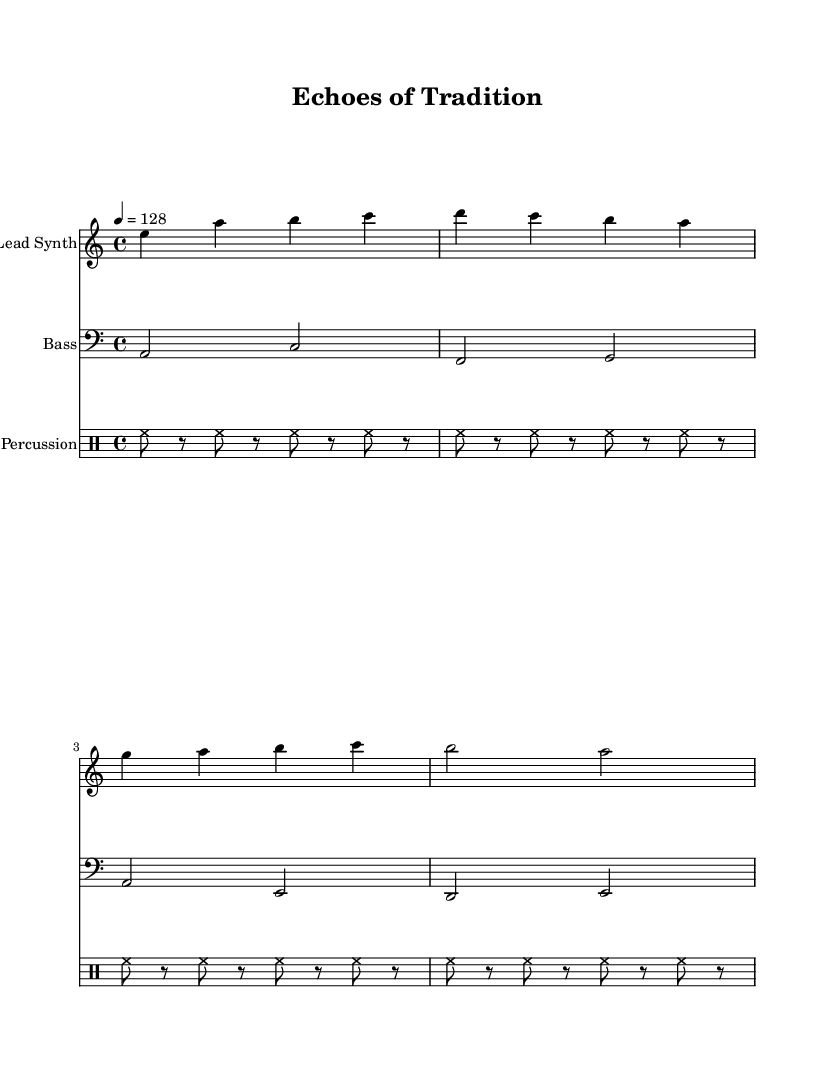What is the key signature of this music? The key signature is A minor, which has no sharps or flats.
Answer: A minor What is the time signature of this music? The time signature is 4/4, indicating four beats in a measure and a quarter note receives one beat.
Answer: 4/4 What is the tempo marking of this piece? The tempo marking is 128 beats per minute, indicating that the piece should be played at a relatively fast pace.
Answer: 128 How many measures are in the lead synth part? There are eight measures in the lead synth part, as counted from the notation provided.
Answer: 8 What is the highest note played by the lead synth? The highest note played by the lead synth is C, as seen in the notation.
Answer: C Which drum rhythm is predominantly used in this piece? The predominant drum rhythm is the hi-hat pattern, which consists of alternating hi-hat and rests, creating a consistent groove.
Answer: Hi-hat What is the relationship between the bass and lead synth parts? The bass complements the lead synth by playing lower harmonies that correspond to the melodic content in the lead synth, establishing a fuller sound.
Answer: Complementary 